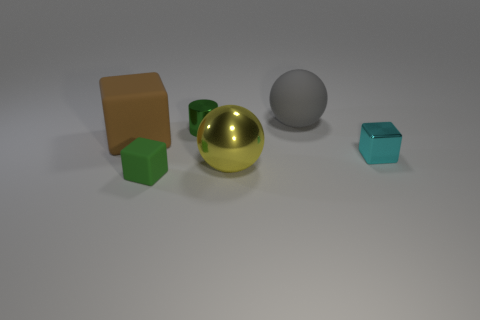Subtract all tiny cubes. How many cubes are left? 1 Add 3 tiny metallic cylinders. How many objects exist? 9 Subtract all yellow spheres. How many spheres are left? 1 Subtract 1 spheres. How many spheres are left? 1 Subtract all spheres. How many objects are left? 4 Subtract all red cylinders. How many yellow cubes are left? 0 Subtract all gray objects. Subtract all shiny spheres. How many objects are left? 4 Add 3 cyan metal things. How many cyan metal things are left? 4 Add 3 green cylinders. How many green cylinders exist? 4 Subtract 1 gray spheres. How many objects are left? 5 